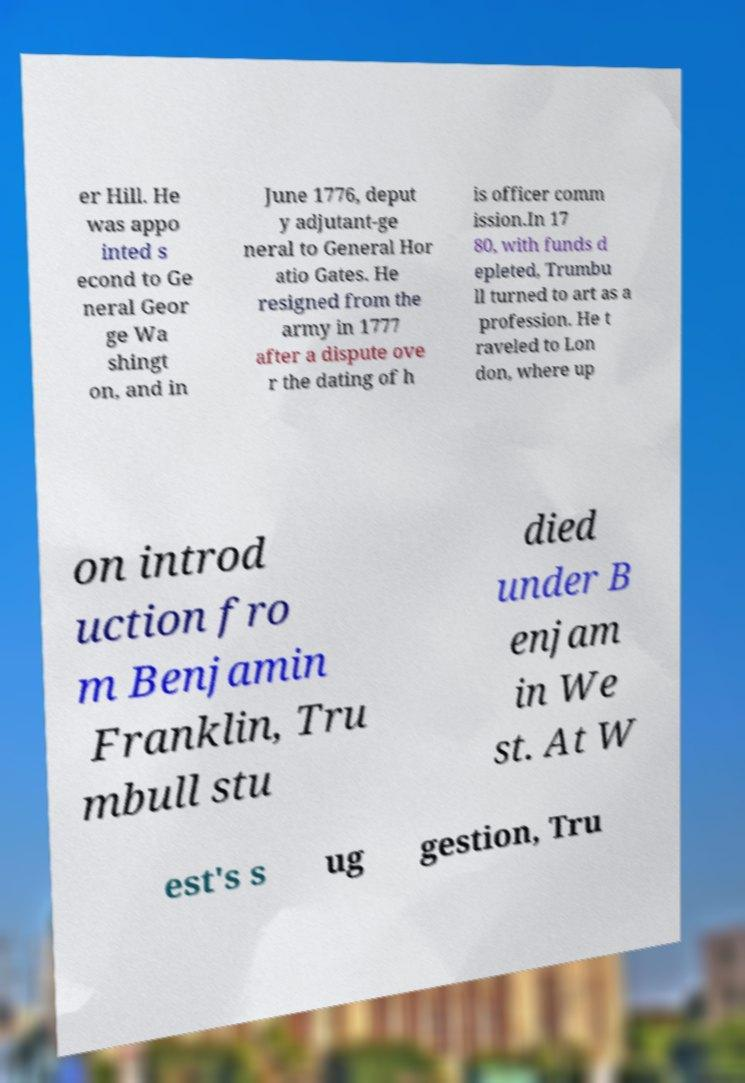Can you read and provide the text displayed in the image?This photo seems to have some interesting text. Can you extract and type it out for me? er Hill. He was appo inted s econd to Ge neral Geor ge Wa shingt on, and in June 1776, deput y adjutant-ge neral to General Hor atio Gates. He resigned from the army in 1777 after a dispute ove r the dating of h is officer comm ission.In 17 80, with funds d epleted, Trumbu ll turned to art as a profession. He t raveled to Lon don, where up on introd uction fro m Benjamin Franklin, Tru mbull stu died under B enjam in We st. At W est's s ug gestion, Tru 